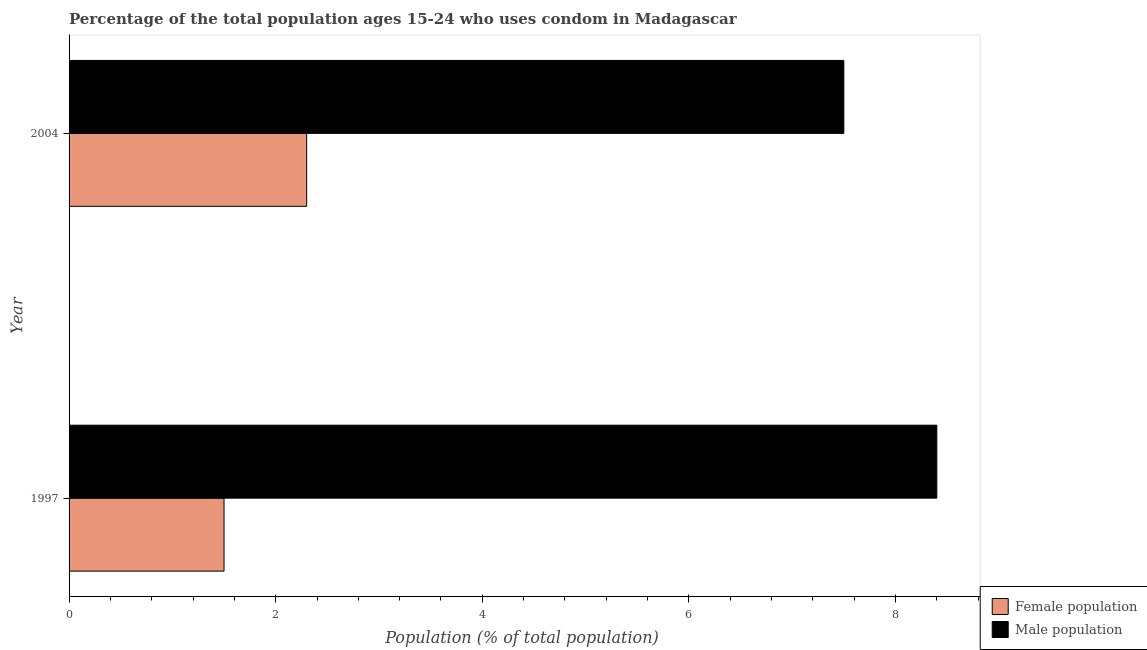How many different coloured bars are there?
Your answer should be compact. 2. Are the number of bars per tick equal to the number of legend labels?
Make the answer very short. Yes. Are the number of bars on each tick of the Y-axis equal?
Your response must be concise. Yes. In how many cases, is the number of bars for a given year not equal to the number of legend labels?
Give a very brief answer. 0. Across all years, what is the minimum male population?
Provide a succinct answer. 7.5. What is the difference between the male population in 1997 and that in 2004?
Offer a terse response. 0.9. What is the difference between the male population in 1997 and the female population in 2004?
Your response must be concise. 6.1. What is the average female population per year?
Offer a very short reply. 1.9. What is the ratio of the female population in 1997 to that in 2004?
Ensure brevity in your answer.  0.65. Is the difference between the female population in 1997 and 2004 greater than the difference between the male population in 1997 and 2004?
Ensure brevity in your answer.  No. What does the 1st bar from the top in 2004 represents?
Provide a succinct answer. Male population. What does the 1st bar from the bottom in 2004 represents?
Make the answer very short. Female population. How many bars are there?
Give a very brief answer. 4. How many years are there in the graph?
Offer a very short reply. 2. What is the difference between two consecutive major ticks on the X-axis?
Keep it short and to the point. 2. Are the values on the major ticks of X-axis written in scientific E-notation?
Your response must be concise. No. Does the graph contain any zero values?
Your answer should be very brief. No. Does the graph contain grids?
Offer a very short reply. No. Where does the legend appear in the graph?
Provide a succinct answer. Bottom right. How many legend labels are there?
Provide a succinct answer. 2. How are the legend labels stacked?
Keep it short and to the point. Vertical. What is the title of the graph?
Provide a succinct answer. Percentage of the total population ages 15-24 who uses condom in Madagascar. What is the label or title of the X-axis?
Offer a terse response. Population (% of total population) . What is the label or title of the Y-axis?
Ensure brevity in your answer.  Year. Across all years, what is the maximum Population (% of total population)  in Female population?
Your answer should be very brief. 2.3. Across all years, what is the minimum Population (% of total population)  of Female population?
Make the answer very short. 1.5. Across all years, what is the minimum Population (% of total population)  in Male population?
Offer a terse response. 7.5. What is the total Population (% of total population)  of Female population in the graph?
Offer a very short reply. 3.8. What is the total Population (% of total population)  in Male population in the graph?
Provide a short and direct response. 15.9. What is the difference between the Population (% of total population)  in Female population in 1997 and that in 2004?
Provide a short and direct response. -0.8. What is the average Population (% of total population)  in Male population per year?
Your answer should be compact. 7.95. What is the ratio of the Population (% of total population)  of Female population in 1997 to that in 2004?
Ensure brevity in your answer.  0.65. What is the ratio of the Population (% of total population)  in Male population in 1997 to that in 2004?
Give a very brief answer. 1.12. What is the difference between the highest and the second highest Population (% of total population)  in Female population?
Ensure brevity in your answer.  0.8. What is the difference between the highest and the lowest Population (% of total population)  in Female population?
Ensure brevity in your answer.  0.8. 